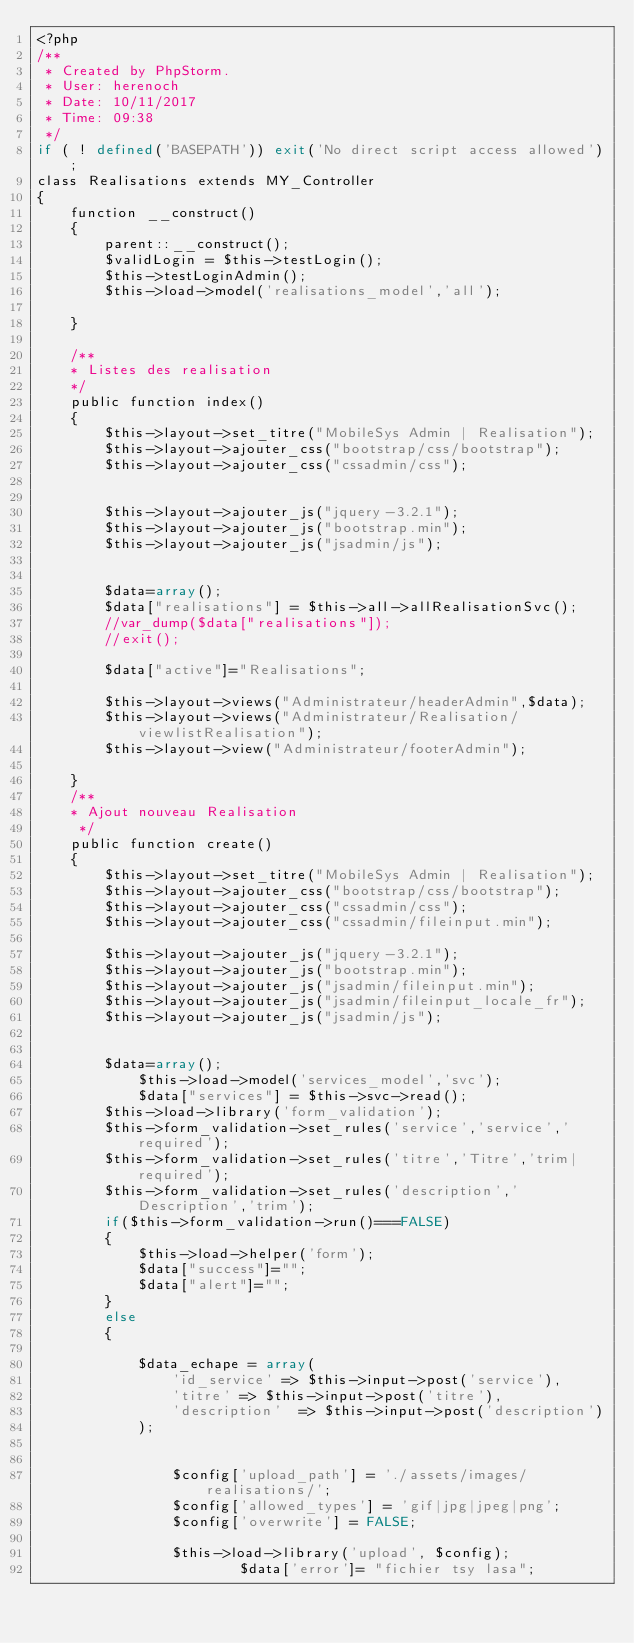<code> <loc_0><loc_0><loc_500><loc_500><_PHP_><?php
/**
 * Created by PhpStorm.
 * User: herenoch
 * Date: 10/11/2017
 * Time: 09:38
 */
if ( ! defined('BASEPATH')) exit('No direct script access allowed');
class Realisations extends MY_Controller
{
    function __construct()
    {
        parent::__construct();
        $validLogin = $this->testLogin();
        $this->testLoginAdmin();
		$this->load->model('realisations_model','all');

    }

    /**
    * Listes des realisation
    */
    public function index()
    {
        $this->layout->set_titre("MobileSys Admin | Realisation");
        $this->layout->ajouter_css("bootstrap/css/bootstrap");
        $this->layout->ajouter_css("cssadmin/css");


        $this->layout->ajouter_js("jquery-3.2.1");
        $this->layout->ajouter_js("bootstrap.min");
        $this->layout->ajouter_js("jsadmin/js");


        $data=array();
		$data["realisations"] = $this->all->allRealisationSvc();
        //var_dump($data["realisations"]);
        //exit();

        $data["active"]="Realisations";

        $this->layout->views("Administrateur/headerAdmin",$data);
        $this->layout->views("Administrateur/Realisation/viewlistRealisation");
        $this->layout->view("Administrateur/footerAdmin");

    }
    /**
    * Ajout nouveau Realisation
     */
    public function create()
    {
        $this->layout->set_titre("MobileSys Admin | Realisation");
        $this->layout->ajouter_css("bootstrap/css/bootstrap");
        $this->layout->ajouter_css("cssadmin/css");
        $this->layout->ajouter_css("cssadmin/fileinput.min");

        $this->layout->ajouter_js("jquery-3.2.1");
        $this->layout->ajouter_js("bootstrap.min");
        $this->layout->ajouter_js("jsadmin/fileinput.min");
        $this->layout->ajouter_js("jsadmin/fileinput_locale_fr");
        $this->layout->ajouter_js("jsadmin/js");


        $data=array();
			$this->load->model('services_model','svc');
			$data["services"] = $this->svc->read();
        $this->load->library('form_validation');
        $this->form_validation->set_rules('service','service','required');
        $this->form_validation->set_rules('titre','Titre','trim|required');
        $this->form_validation->set_rules('description','Description','trim');
        if($this->form_validation->run()===FALSE)
        {
            $this->load->helper('form');
			$data["success"]="";
			$data["alert"]="";
        }
        else
        {

            $data_echape = array(
                'id_service' => $this->input->post('service'),
                'titre' => $this->input->post('titre'),
                'description'  => $this->input->post('description')
            );
			
			
				$config['upload_path'] = './assets/images/realisations/';
				$config['allowed_types'] = 'gif|jpg|jpeg|png';
				$config['overwrite'] = FALSE;

				$this->load->library('upload', $config);
                        $data['error']= "fichier tsy lasa";
				</code> 